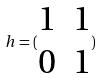Convert formula to latex. <formula><loc_0><loc_0><loc_500><loc_500>h = ( \begin{matrix} 1 & 1 \\ 0 & 1 \end{matrix} )</formula> 